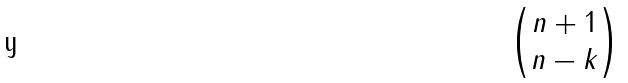Convert formula to latex. <formula><loc_0><loc_0><loc_500><loc_500>\begin{pmatrix} n + 1 \\ n - k \end{pmatrix}</formula> 